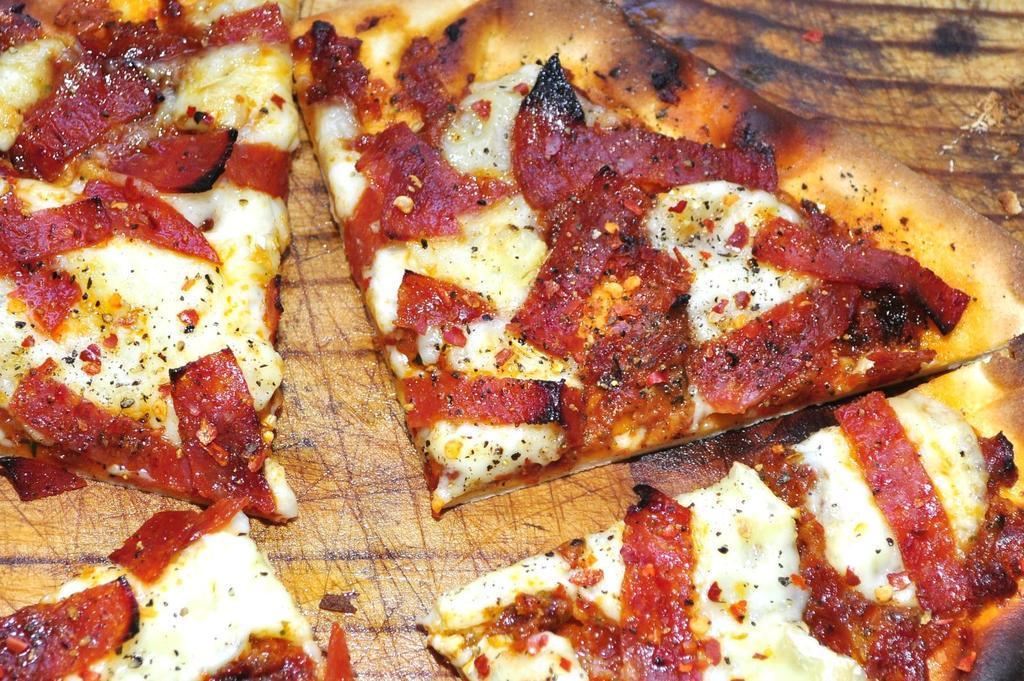Can you describe this image briefly? This image consist of food. 